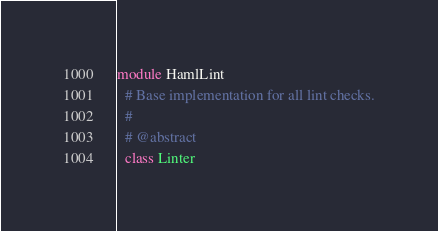Convert code to text. <code><loc_0><loc_0><loc_500><loc_500><_Ruby_>module HamlLint
  # Base implementation for all lint checks.
  #
  # @abstract
  class Linter</code> 